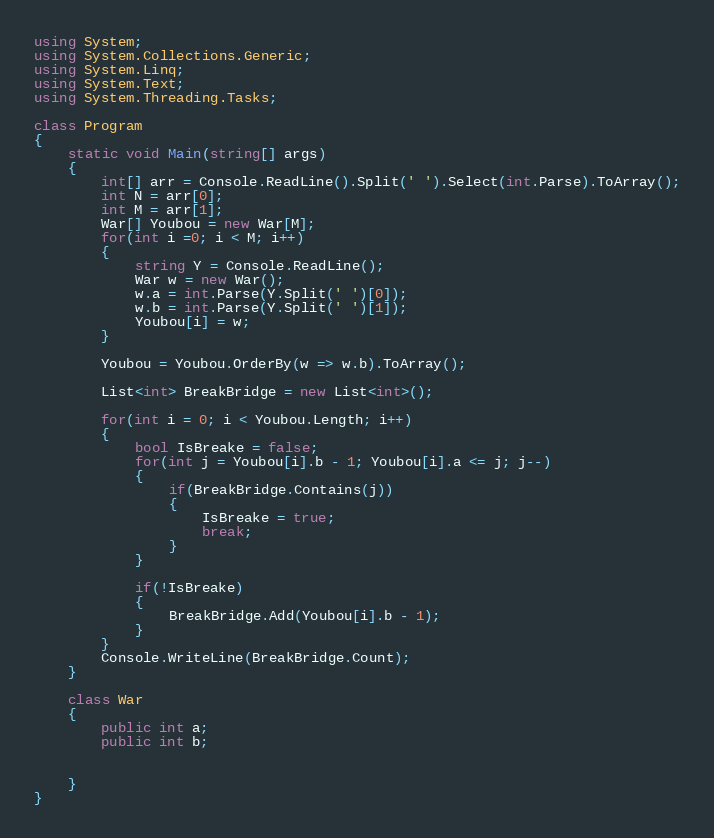<code> <loc_0><loc_0><loc_500><loc_500><_C#_>using System;
using System.Collections.Generic;
using System.Linq;
using System.Text;
using System.Threading.Tasks;

class Program
{
    static void Main(string[] args)
    {
        int[] arr = Console.ReadLine().Split(' ').Select(int.Parse).ToArray();
        int N = arr[0];
        int M = arr[1];
        War[] Youbou = new War[M];
        for(int i =0; i < M; i++)
        {
            string Y = Console.ReadLine();
            War w = new War();
            w.a = int.Parse(Y.Split(' ')[0]);
            w.b = int.Parse(Y.Split(' ')[1]);
            Youbou[i] = w;
        }

        Youbou = Youbou.OrderBy(w => w.b).ToArray();

        List<int> BreakBridge = new List<int>();

        for(int i = 0; i < Youbou.Length; i++)
        {
            bool IsBreake = false;
            for(int j = Youbou[i].b - 1; Youbou[i].a <= j; j--)
            {
                if(BreakBridge.Contains(j))
                {
                    IsBreake = true;
                    break;
                }
            }

            if(!IsBreake)
            {
                BreakBridge.Add(Youbou[i].b - 1);
            }
        }
        Console.WriteLine(BreakBridge.Count);
    }

    class War
    {
        public int a;
        public int b;

        
    }
}

</code> 